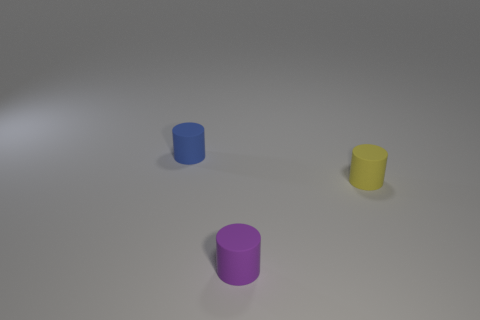What number of purple matte objects are behind the tiny matte cylinder behind the tiny yellow matte cylinder?
Ensure brevity in your answer.  0. What number of tiny purple rubber things are the same shape as the small blue rubber object?
Keep it short and to the point. 1. There is a rubber object on the right side of the tiny purple object; is it the same shape as the small object in front of the tiny yellow rubber thing?
Offer a very short reply. Yes. There is a purple cylinder to the left of the yellow rubber cylinder that is behind the purple cylinder; how many rubber objects are in front of it?
Offer a terse response. 0. What is the material of the tiny thing in front of the object that is on the right side of the purple object that is in front of the tiny yellow object?
Keep it short and to the point. Rubber. Does the blue object to the left of the small purple cylinder have the same material as the yellow cylinder?
Provide a short and direct response. Yes. How many blue cylinders are the same size as the yellow rubber cylinder?
Keep it short and to the point. 1. Is the number of matte cylinders that are behind the small blue thing greater than the number of tiny rubber cylinders left of the small yellow rubber thing?
Provide a succinct answer. No. Is there a yellow object that has the same shape as the blue matte object?
Your answer should be compact. Yes. How big is the matte cylinder that is in front of the thing that is right of the purple rubber cylinder?
Your answer should be very brief. Small. 